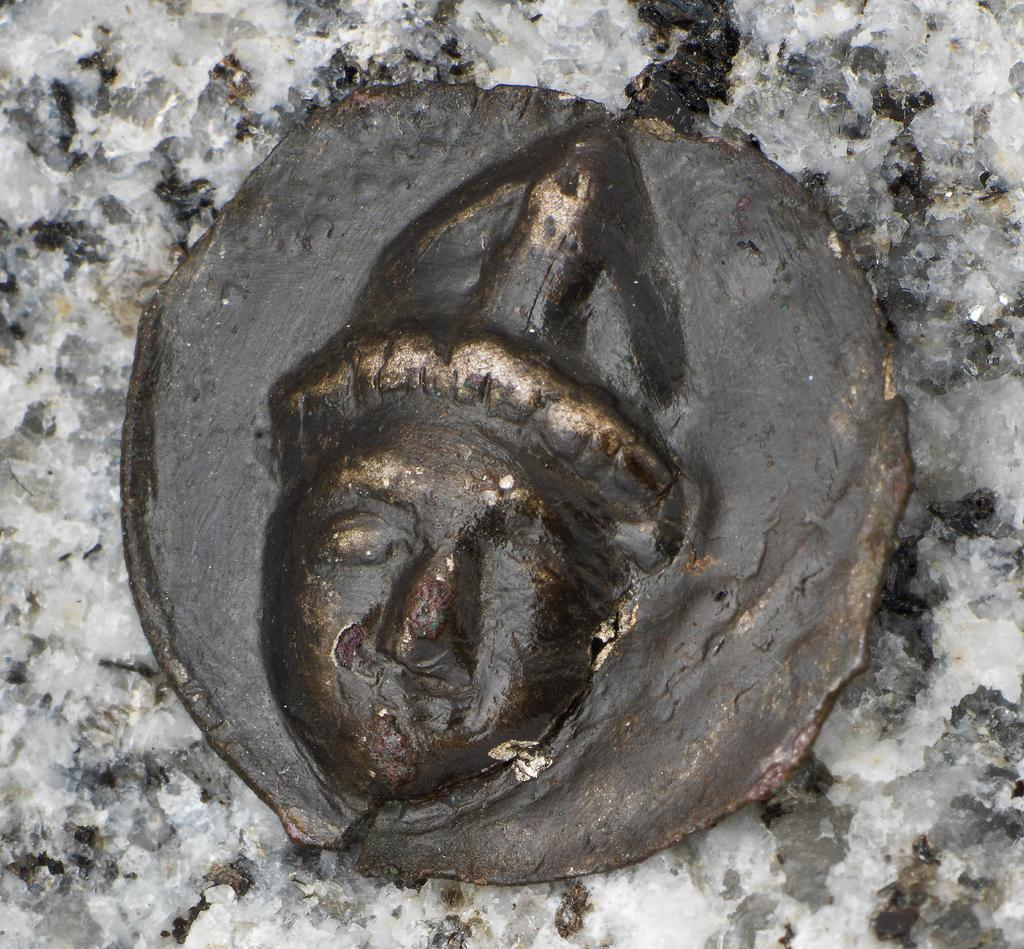What is the main subject in the image? There is a black color thing in the image. Can you describe the background of the image? There is white color visible in the background of the image. Where is the toy banana located on the train in the image? There is no toy, banana, or train present in the image. 